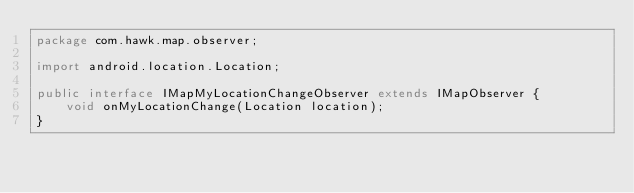Convert code to text. <code><loc_0><loc_0><loc_500><loc_500><_Java_>package com.hawk.map.observer;

import android.location.Location;

public interface IMapMyLocationChangeObserver extends IMapObserver {
	void onMyLocationChange(Location location);
}
</code> 